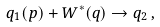Convert formula to latex. <formula><loc_0><loc_0><loc_500><loc_500>q _ { 1 } ( p ) + W ^ { * } ( q ) \to q _ { 2 } \, ,</formula> 